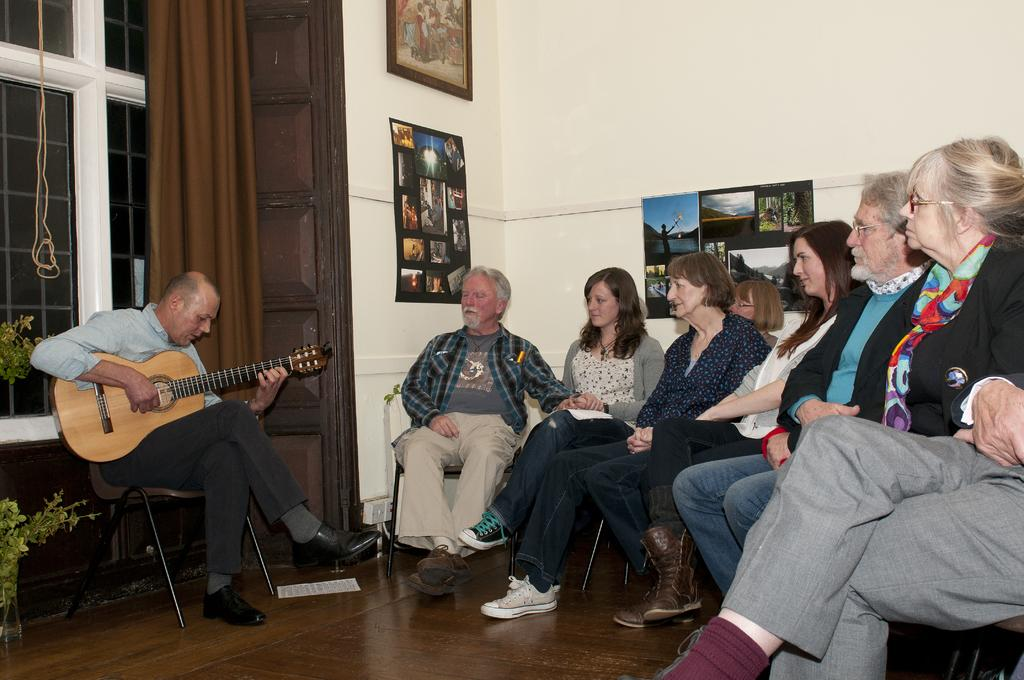What is the man in the image doing? The man is playing a guitar in the image. Who else is present in the image besides the man? There is a group of people in the image. What are the group of people doing? The group of people are listening to the man playing the guitar. What is the weight of the salt in the image? There is no salt present in the image, so it is not possible to determine its weight. 